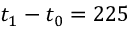<formula> <loc_0><loc_0><loc_500><loc_500>t _ { 1 } - t _ { 0 } = 2 2 5</formula> 